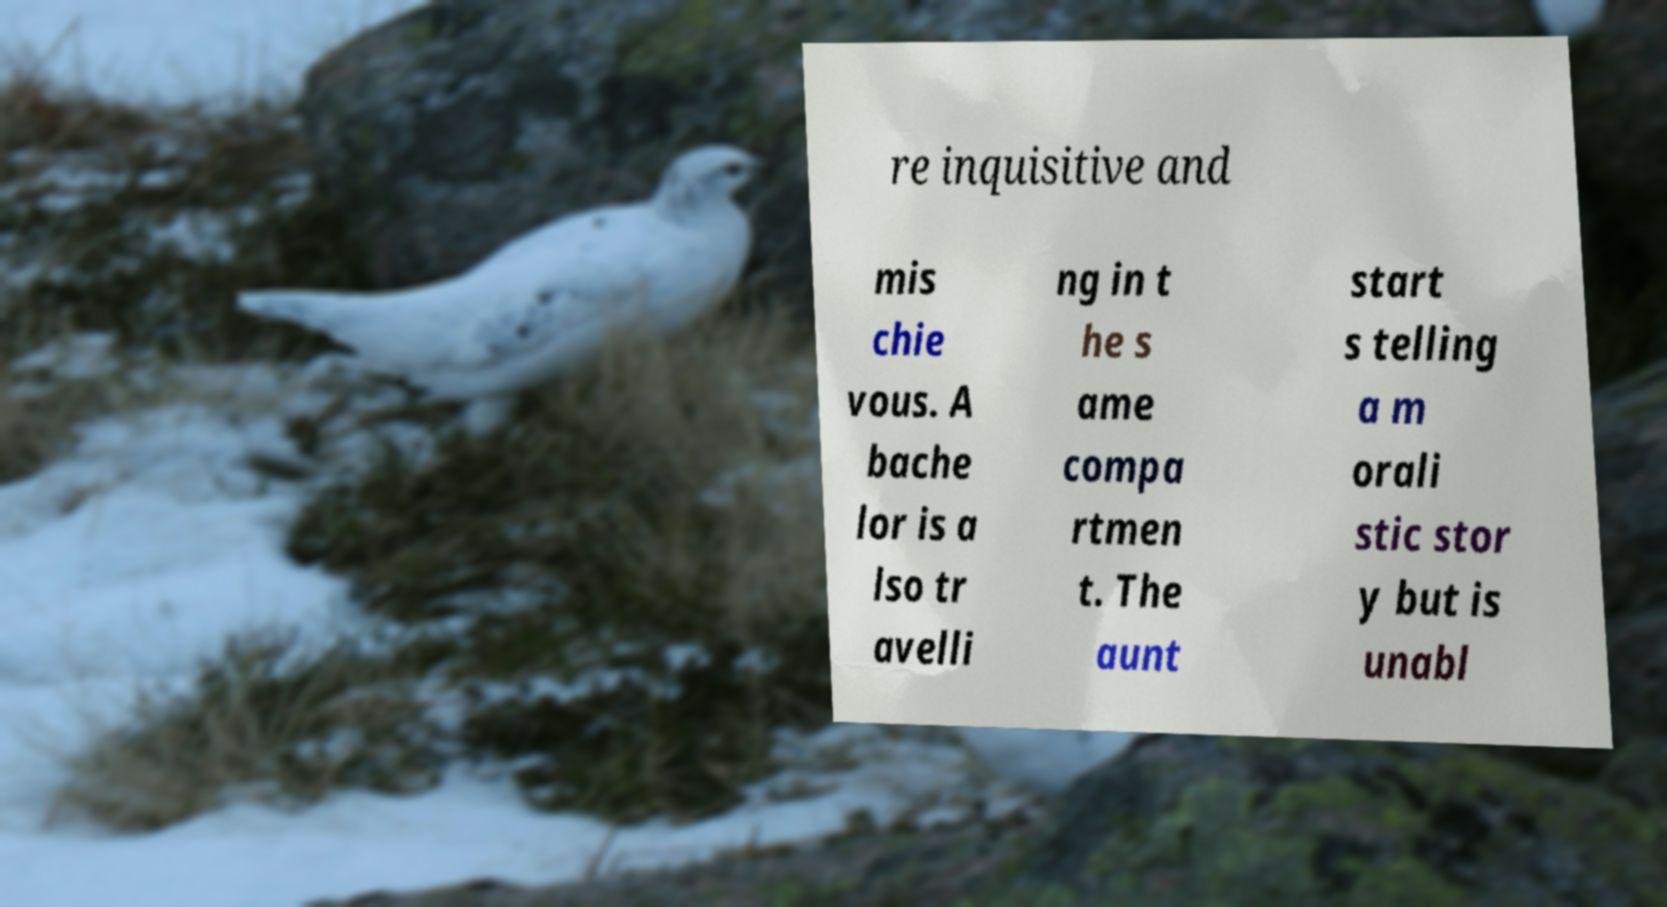I need the written content from this picture converted into text. Can you do that? re inquisitive and mis chie vous. A bache lor is a lso tr avelli ng in t he s ame compa rtmen t. The aunt start s telling a m orali stic stor y but is unabl 